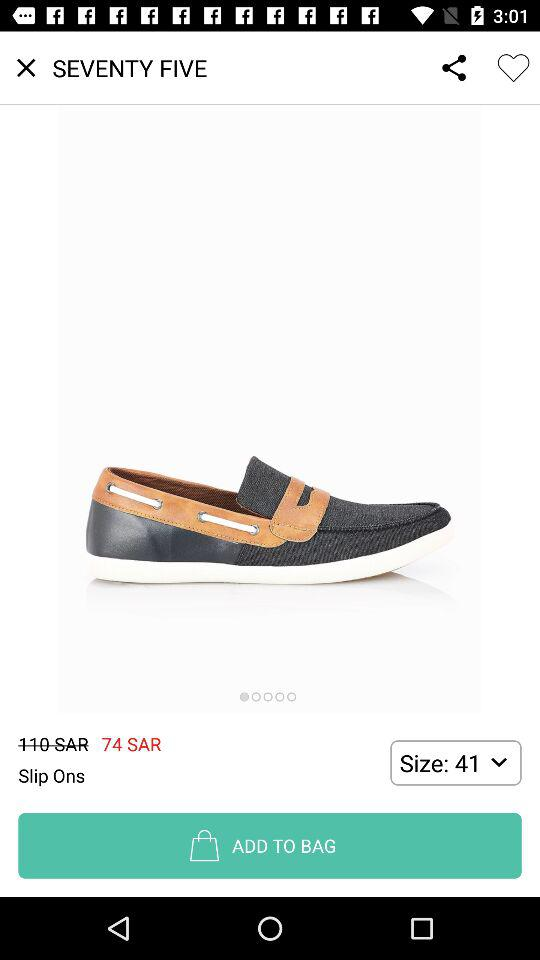What is the difference between the original price and the sale price?
Answer the question using a single word or phrase. 36 